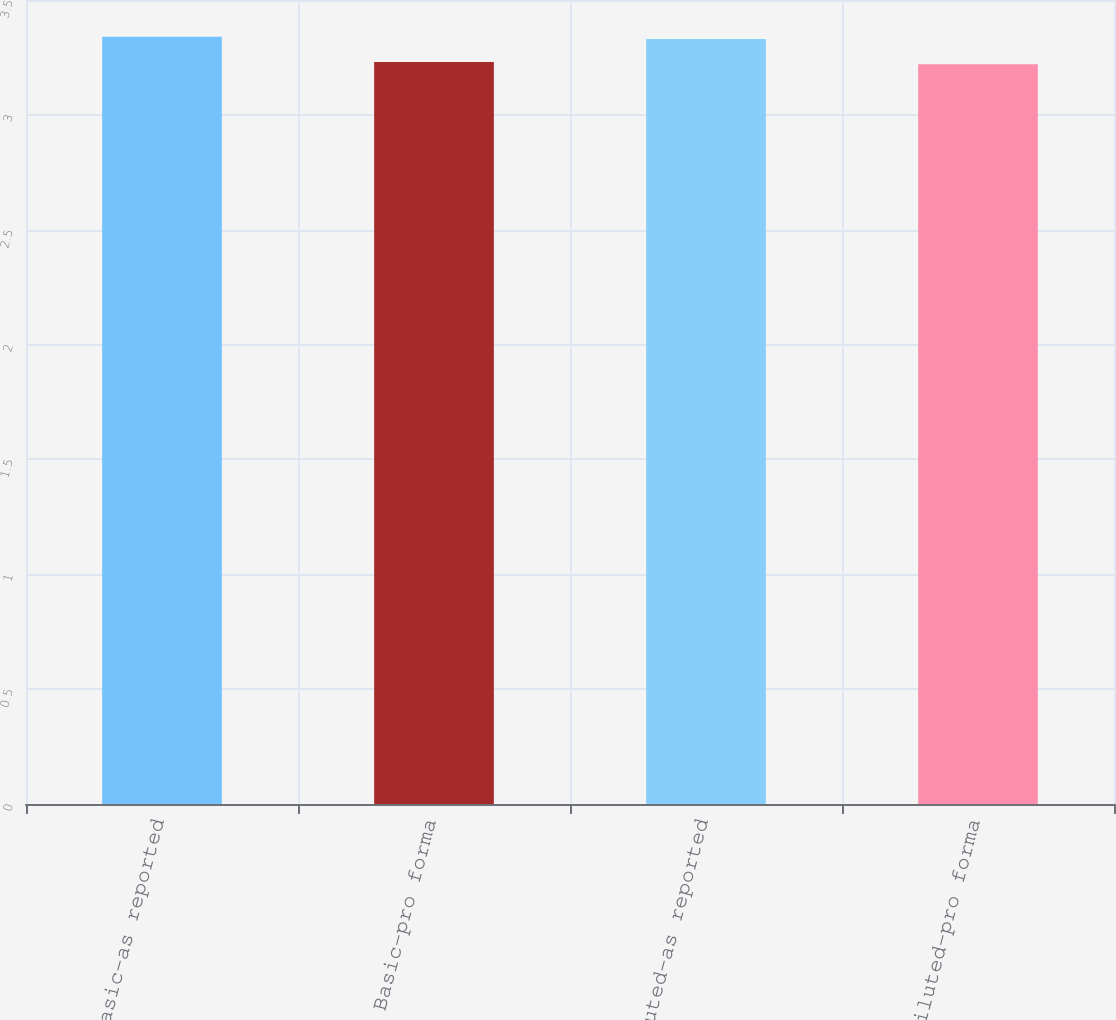<chart> <loc_0><loc_0><loc_500><loc_500><bar_chart><fcel>Basic-as reported<fcel>Basic-pro forma<fcel>Diluted-as reported<fcel>Diluted-pro forma<nl><fcel>3.34<fcel>3.23<fcel>3.33<fcel>3.22<nl></chart> 